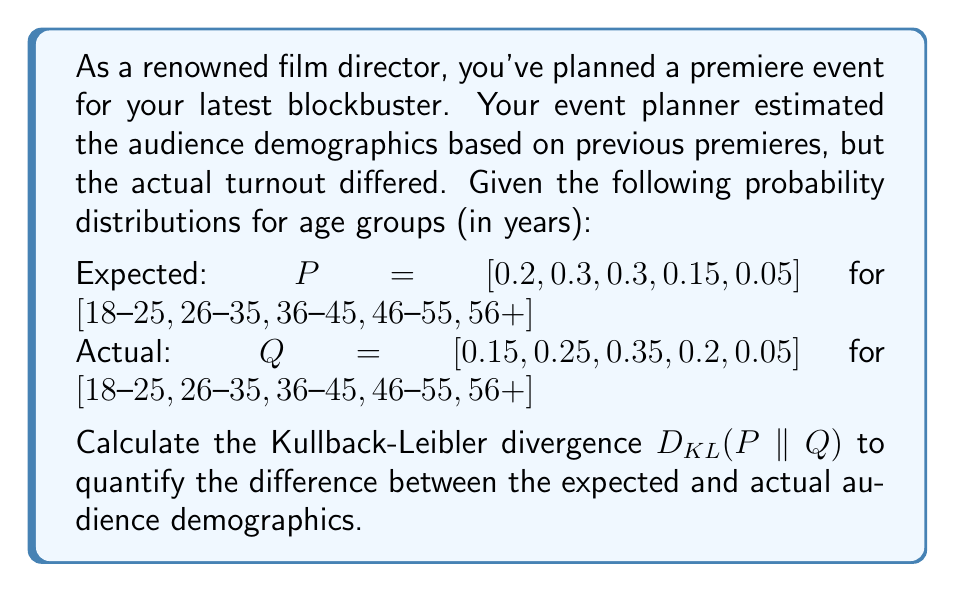What is the answer to this math problem? To solve this problem, we'll use the Kullback-Leibler divergence formula:

$$D_{KL}(P||Q) = \sum_{i} P(i) \log\left(\frac{P(i)}{Q(i)}\right)$$

Where $P(i)$ is the probability of the i-th event in the expected distribution, and $Q(i)$ is the probability of the i-th event in the actual distribution.

Let's calculate each term of the sum:

1. For 18-25 age group:
   $0.2 \log\left(\frac{0.2}{0.15}\right) = 0.2 \log(1.3333) \approx 0.0573$

2. For 26-35 age group:
   $0.3 \log\left(\frac{0.3}{0.25}\right) = 0.3 \log(1.2) \approx 0.0547$

3. For 36-45 age group:
   $0.3 \log\left(\frac{0.3}{0.35}\right) = 0.3 \log(0.8571) \approx -0.0139$

4. For 46-55 age group:
   $0.15 \log\left(\frac{0.15}{0.2}\right) = 0.15 \log(0.75) \approx -0.0432$

5. For 56+ age group:
   $0.05 \log\left(\frac{0.05}{0.05}\right) = 0.05 \log(1) = 0$

Now, we sum up all these terms:

$$D_{KL}(P||Q) = 0.0573 + 0.0547 - 0.0139 - 0.0432 + 0 = 0.0549$$

This value represents the relative entropy or information gain when using the expected distribution instead of the actual distribution.
Answer: The Kullback-Leibler divergence $D_{KL}(P||Q)$ between the expected and actual audience demographics is approximately 0.0549 nats. 